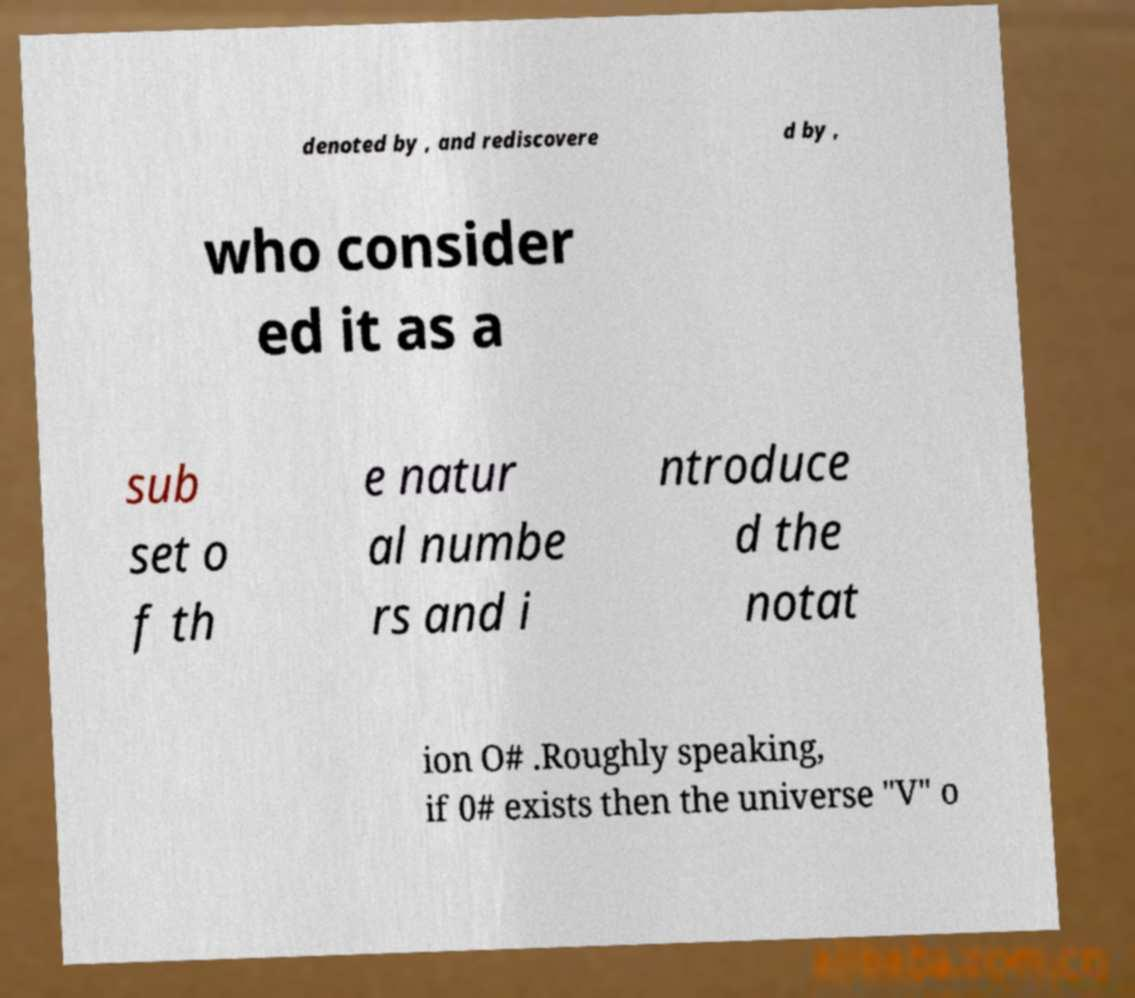Please identify and transcribe the text found in this image. denoted by , and rediscovere d by , who consider ed it as a sub set o f th e natur al numbe rs and i ntroduce d the notat ion O# .Roughly speaking, if 0# exists then the universe "V" o 